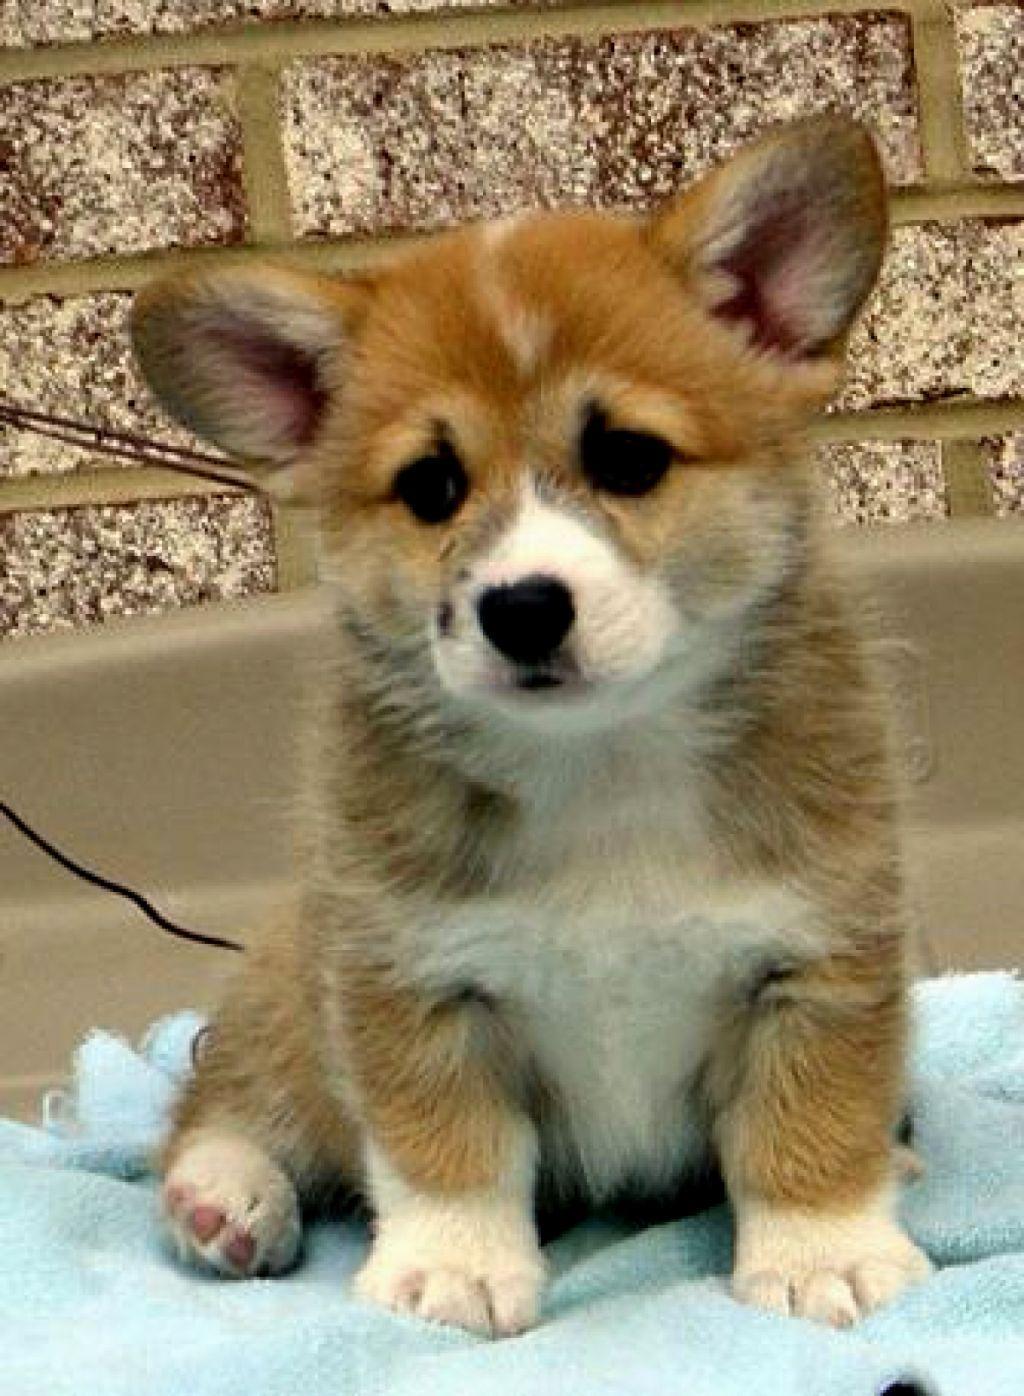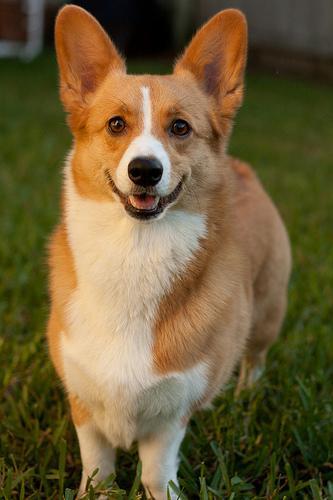The first image is the image on the left, the second image is the image on the right. Examine the images to the left and right. Is the description "An image shows an open-mouthed corgi dog that does not have its tongue hanging to one side." accurate? Answer yes or no. Yes. 